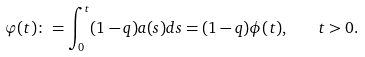Convert formula to latex. <formula><loc_0><loc_0><loc_500><loc_500>\varphi ( t ) \colon = \int _ { 0 } ^ { t } ( 1 - q ) a ( s ) d s = ( 1 - q ) \phi ( t ) , \quad t > 0 .</formula> 